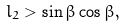Convert formula to latex. <formula><loc_0><loc_0><loc_500><loc_500>l _ { 2 } > \sin \beta \cos \beta ,</formula> 